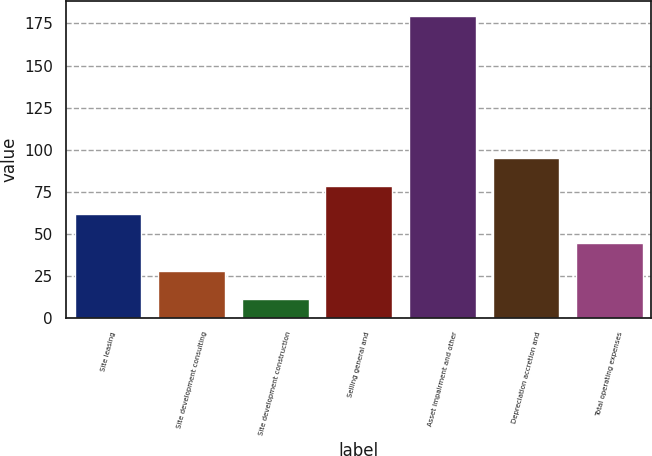<chart> <loc_0><loc_0><loc_500><loc_500><bar_chart><fcel>Site leasing<fcel>Site development consulting<fcel>Site development construction<fcel>Selling general and<fcel>Asset impairment and other<fcel>Depreciation accretion and<fcel>Total operating expenses<nl><fcel>61.58<fcel>27.86<fcel>11<fcel>78.44<fcel>179.6<fcel>95.3<fcel>44.72<nl></chart> 